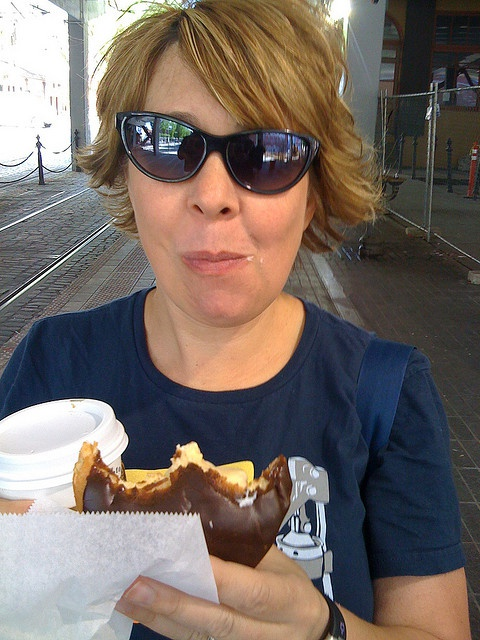Describe the objects in this image and their specific colors. I can see people in white, black, navy, lightgray, and tan tones, donut in white, maroon, brown, and black tones, and cup in white, tan, black, and darkgray tones in this image. 